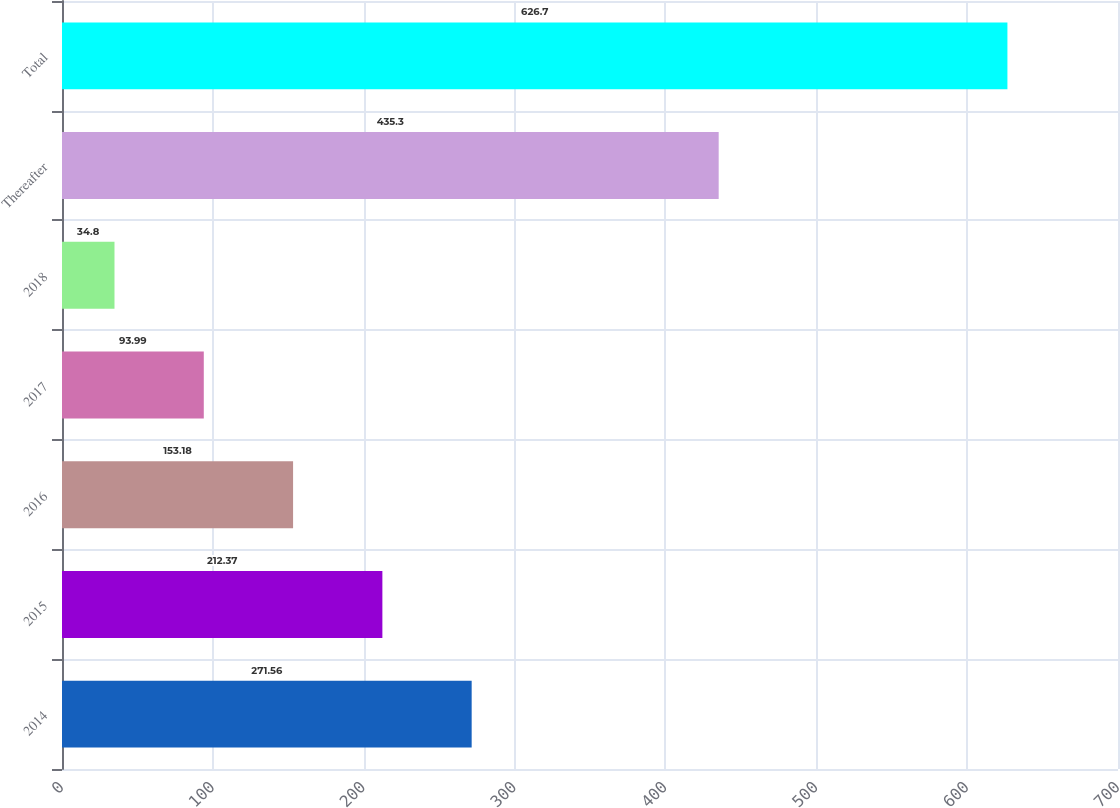Convert chart to OTSL. <chart><loc_0><loc_0><loc_500><loc_500><bar_chart><fcel>2014<fcel>2015<fcel>2016<fcel>2017<fcel>2018<fcel>Thereafter<fcel>Total<nl><fcel>271.56<fcel>212.37<fcel>153.18<fcel>93.99<fcel>34.8<fcel>435.3<fcel>626.7<nl></chart> 